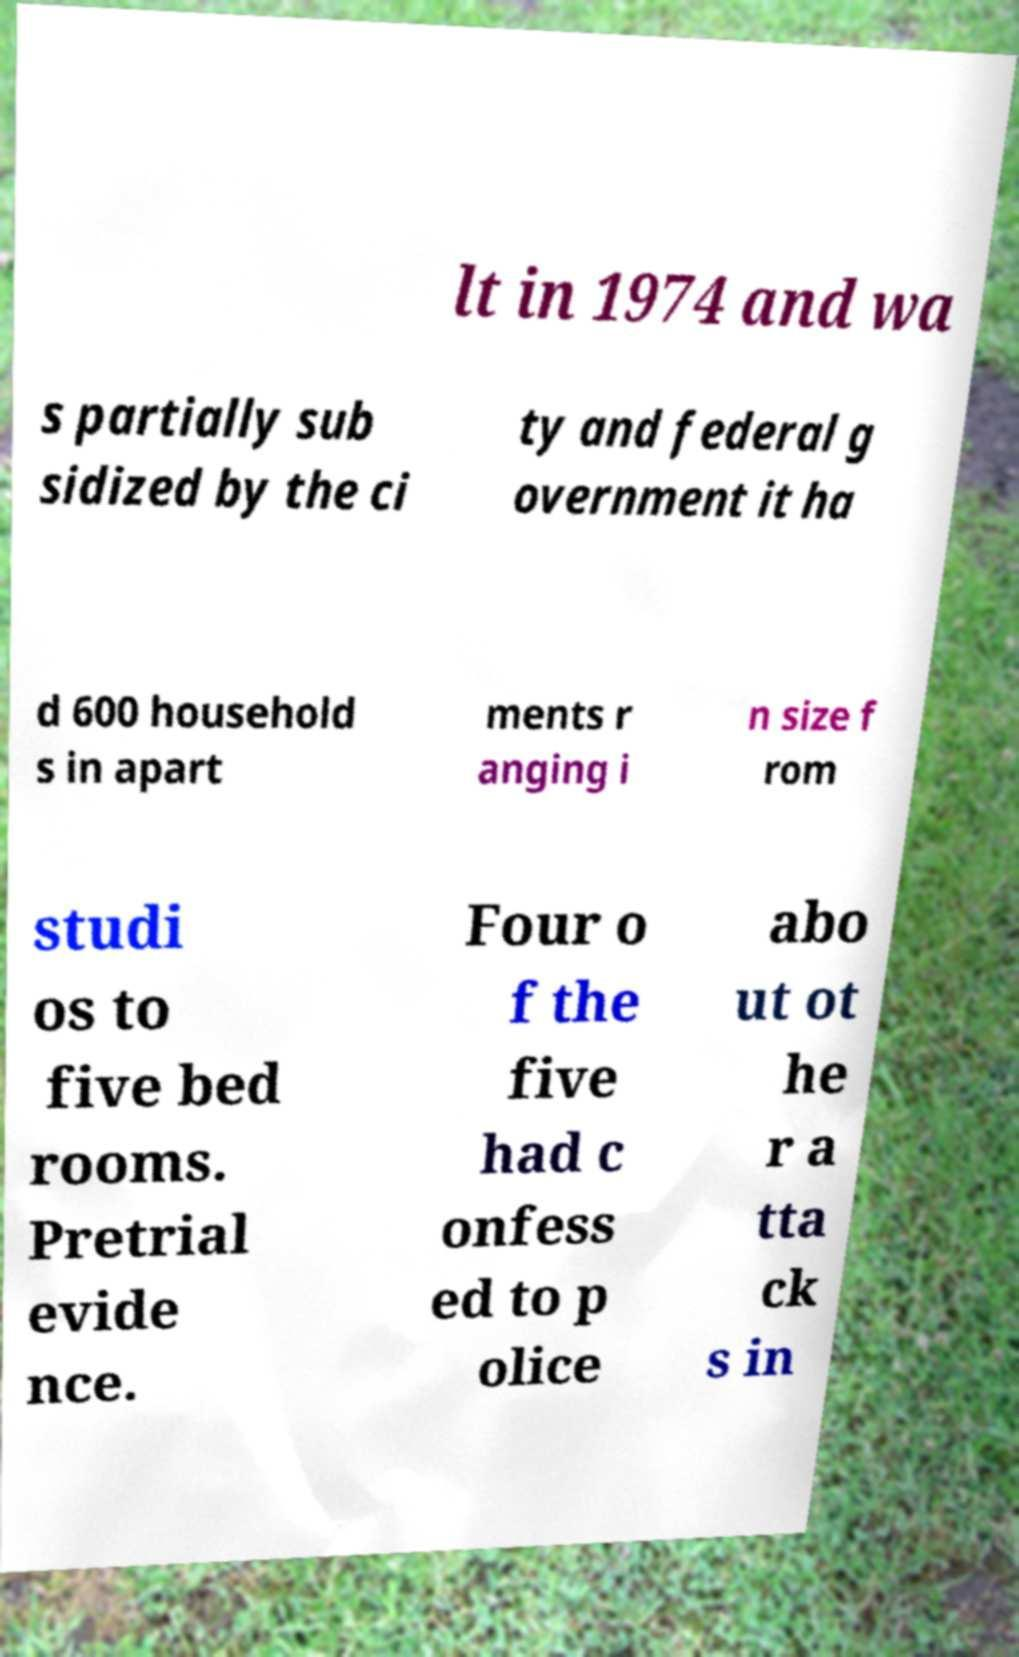Could you assist in decoding the text presented in this image and type it out clearly? lt in 1974 and wa s partially sub sidized by the ci ty and federal g overnment it ha d 600 household s in apart ments r anging i n size f rom studi os to five bed rooms. Pretrial evide nce. Four o f the five had c onfess ed to p olice abo ut ot he r a tta ck s in 